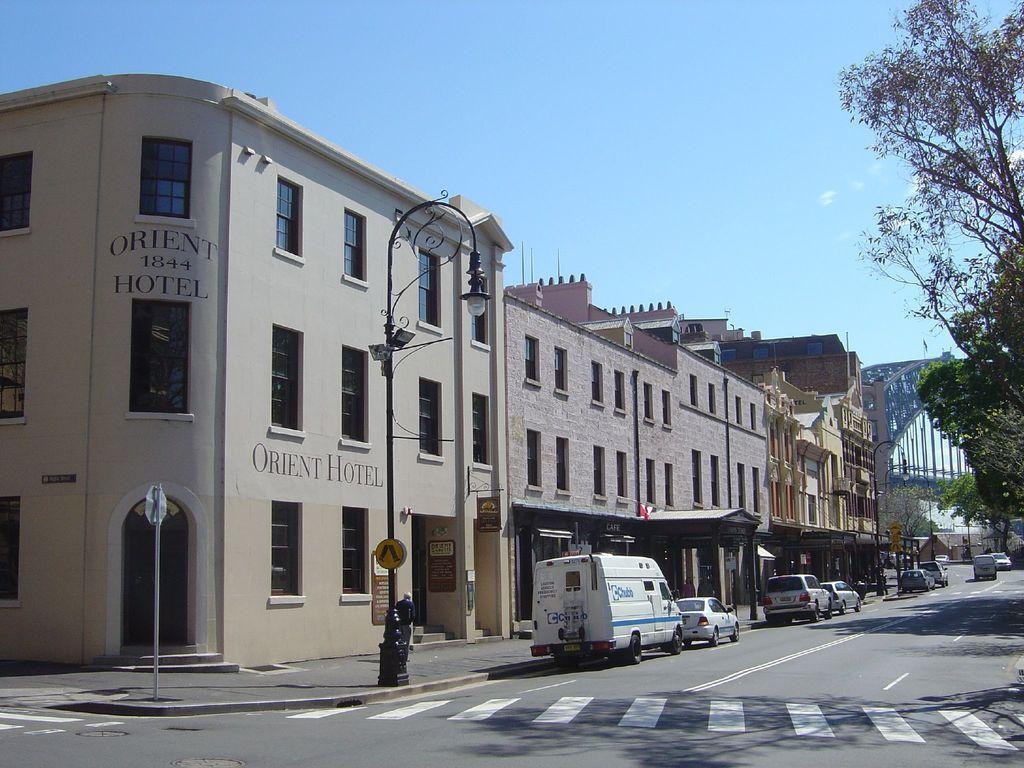Can you describe this image briefly? In this picture we can see there are buildings and in front of the buildings there are some vehicles on the road and poles with sign boards and a light. On the right side of the vehicles there are trees and on the left side of the vehicles a person is walking. On the right side of the buildings, it looks like a bridge. Behind the buildings, there is the sky. 